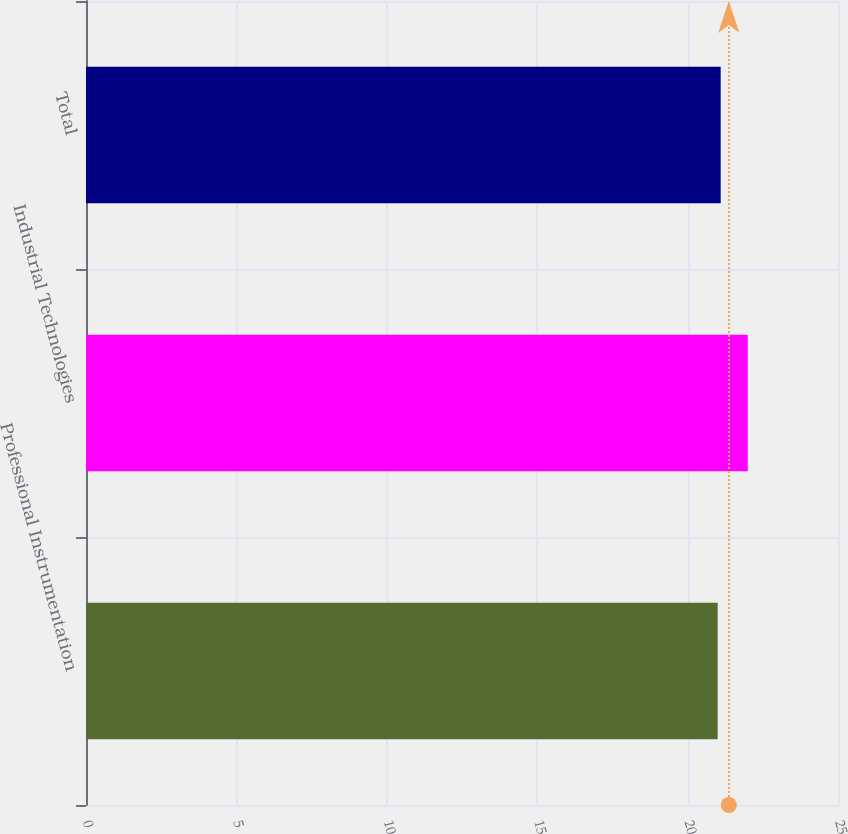<chart> <loc_0><loc_0><loc_500><loc_500><bar_chart><fcel>Professional Instrumentation<fcel>Industrial Technologies<fcel>Total<nl><fcel>21<fcel>22<fcel>21.1<nl></chart> 